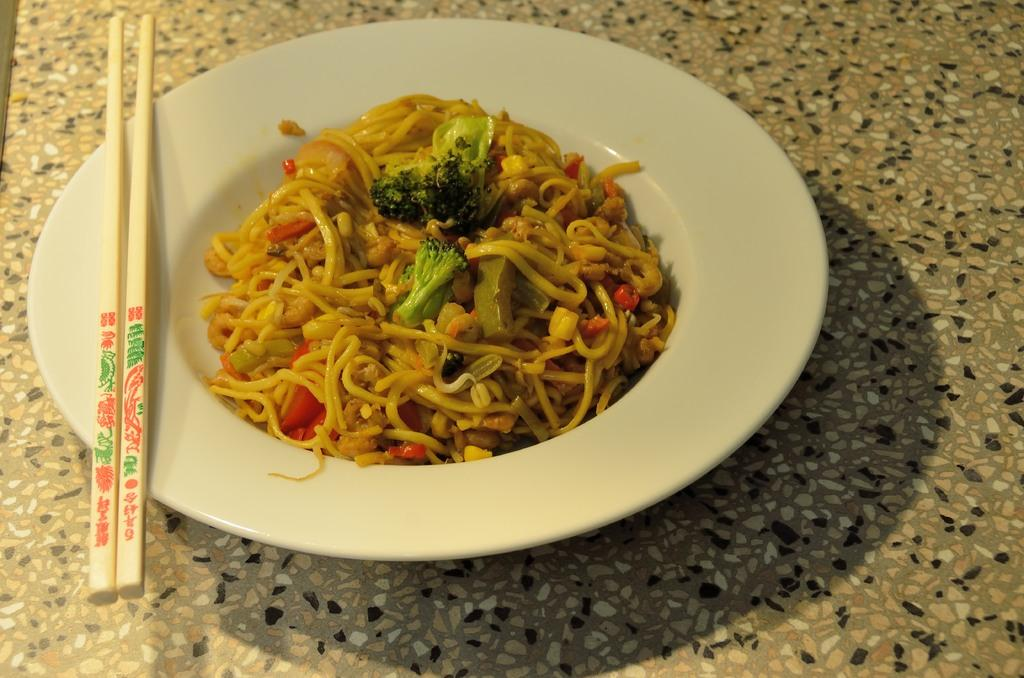What object is on the floor in the image? There is a plate on the floor in the image. What is on the plate? There are food items on the plate. What utensil is present on the plate? There are chopsticks on the plate. How many spiders are crawling on the plate in the image? There are no spiders present on the plate in the image. What type of harmony is being depicted in the image? The image does not depict any specific harmony; it is a plate with food items and chopsticks. What type of leather material is visible in the image? There is no leather material present in the image. 